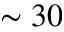Convert formula to latex. <formula><loc_0><loc_0><loc_500><loc_500>\sim 3 0</formula> 